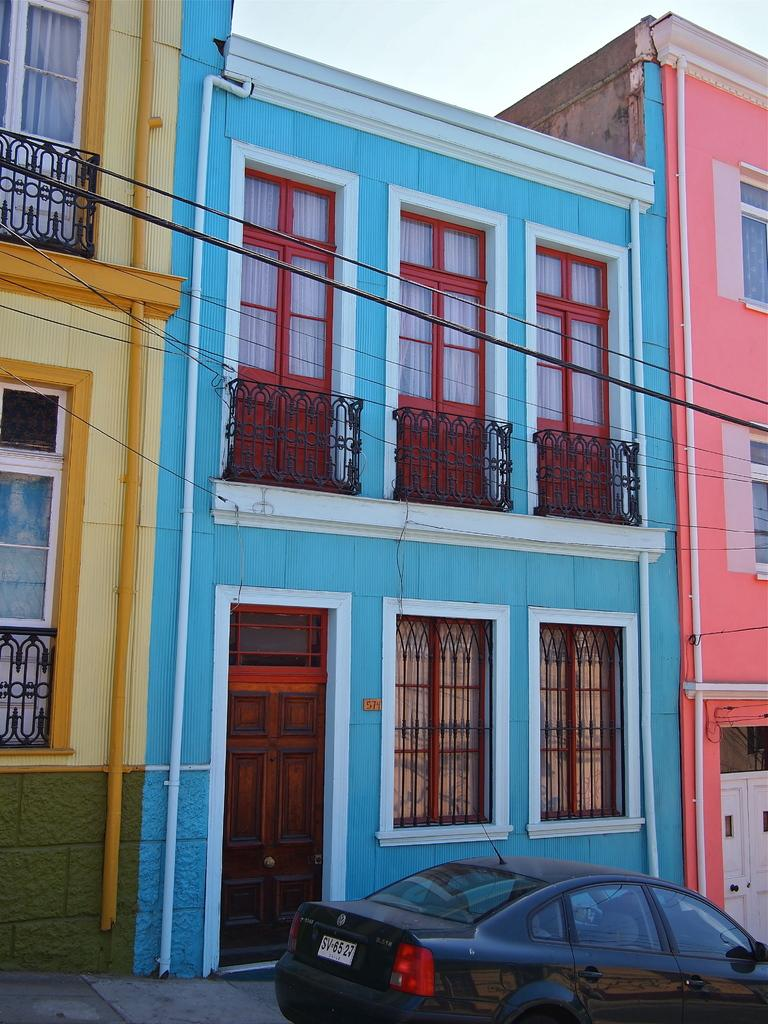What is the main subject of the image? The main subject of the image is a car. What else can be seen in the image besides the car? There is a building in the image. What is visible in the background of the image? The sky is visible in the background of the image. What type of wool can be seen on the car in the image? There is no wool present on the car in the image. How many bikes are parked next to the car in the image? There is no mention of bikes in the image, so we cannot determine if any are present. 